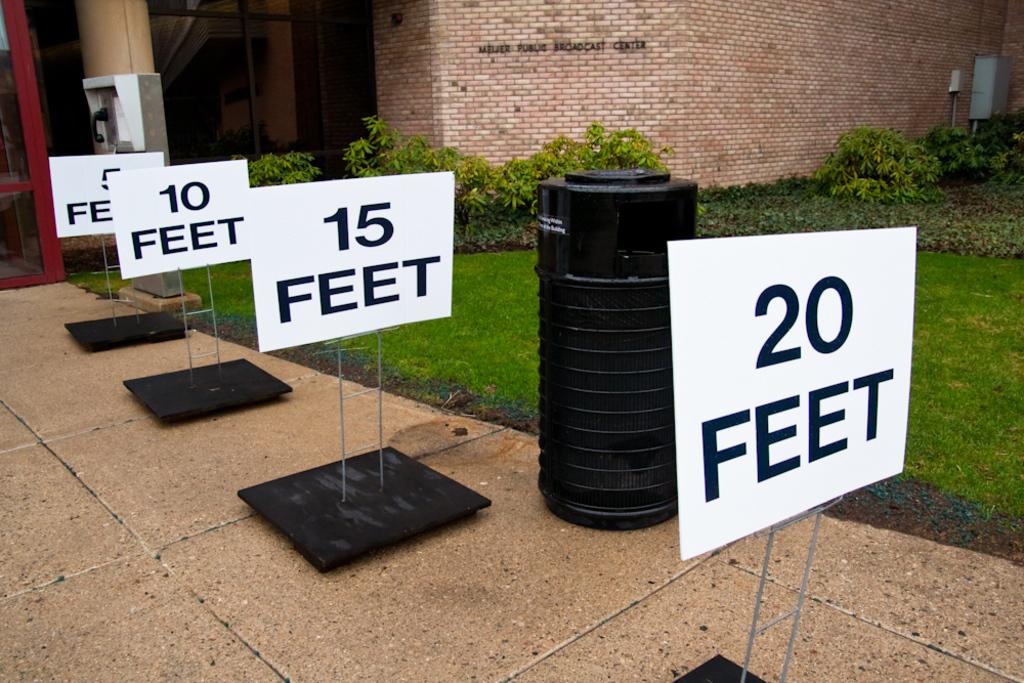What is the distance of the closest sign?
Make the answer very short. 20 feet. 